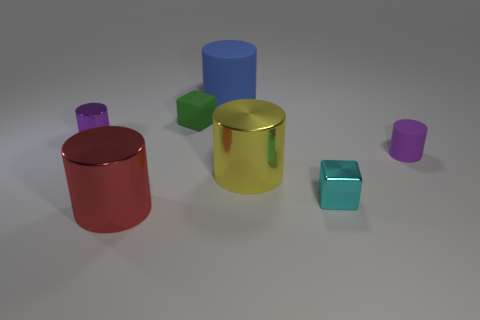Could you recreate this arrangement using everyday household items? Yes, this arrangement could be emulated using household items. You could use cans for the cylinders and boxes or dice for the cubes, choosing those with similar colors and placing them relative to each other as shown in the image. 